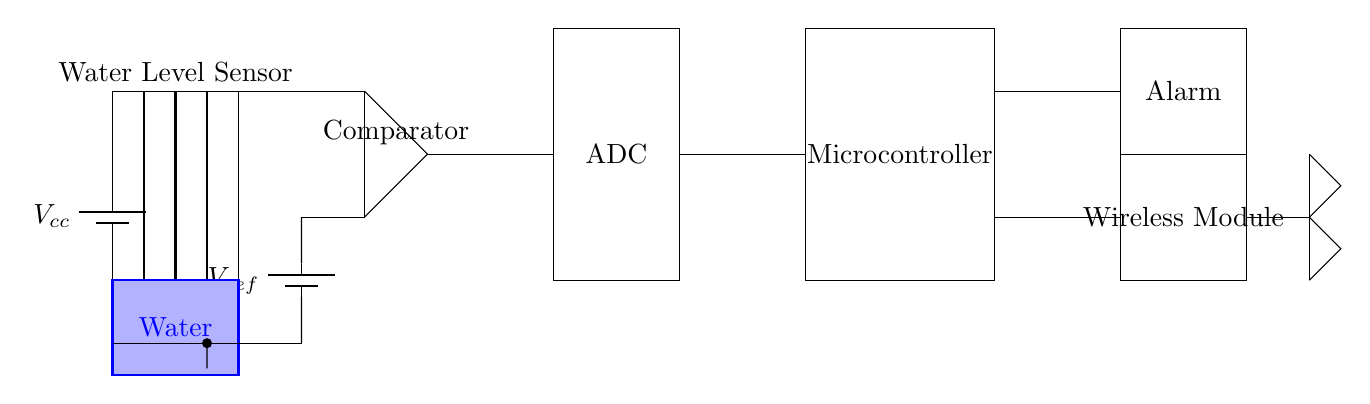What is the function of the water level sensor? The water level sensor detects the level of water, which is indicated at the bottom left of the circuit diagram. This data is crucial for flood detection.
Answer: Water detection What is the reference voltage in this circuit? The reference voltage is indicated as V_ref and provides a comparative voltage level for the comparator to function. The specific value isn't provided in the diagram, but it's an essential component for decision-making in the circuit.
Answer: V_ref What type of output signal does the ADC provide? The ADC, which stands for Analog-to-Digital Converter, translates the analog voltage from the water level sensor into a digital signal that the microcontroller can process.
Answer: Digital signal How does the microcontroller receive water level data? The microcontroller receives data from the ADC through a direct connection, which converts the analog signal into a format that can be used for processing and decision-making within the circuit.
Answer: Through ADC What alerts users of potential flooding in the circuit? The alarm component, which is powered by the system, is triggered by the microcontroller based on the information received from the ADC about water levels that exceed a safe threshold.
Answer: Alarm What is the purpose of the wireless module in the circuit? The wireless module enables remote communication, allowing alerts about rising water levels to be sent to external devices or systems, enhancing the flood detection system's responsiveness.
Answer: Remote communication 